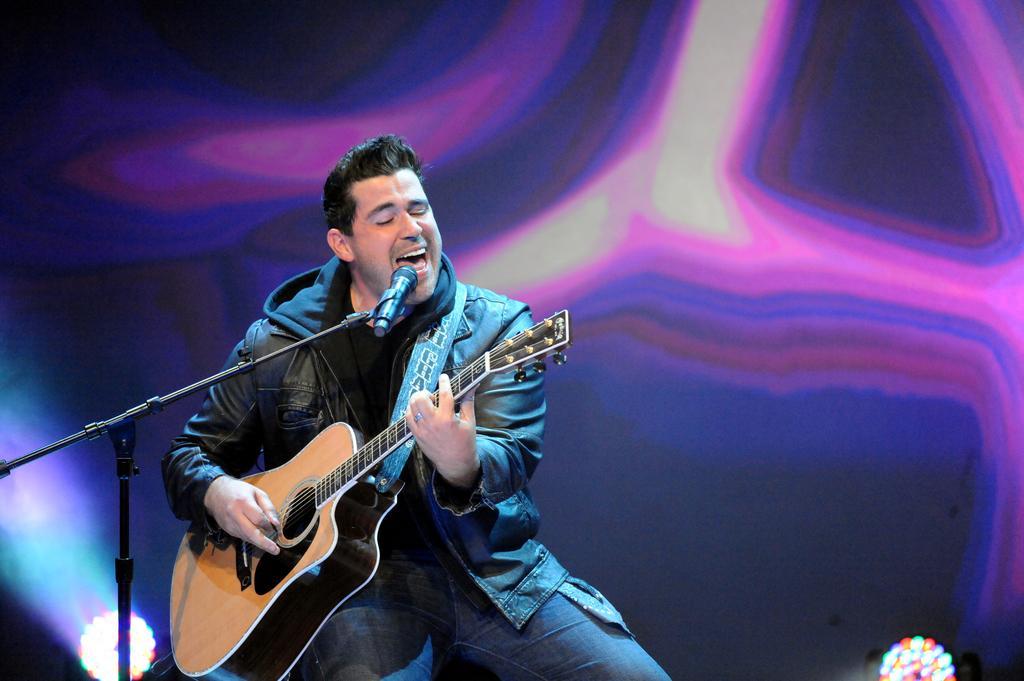Could you give a brief overview of what you see in this image? In the image we can see there is a man who is sitting on a chair and he is holding a guitar. In Front of him there is a mike with a stand and he is wearing a black colour jacket. 